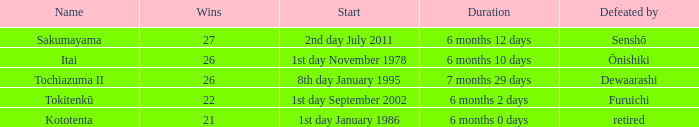Which Start has a Duration of 6 months 2 days? 1st day September 2002. 